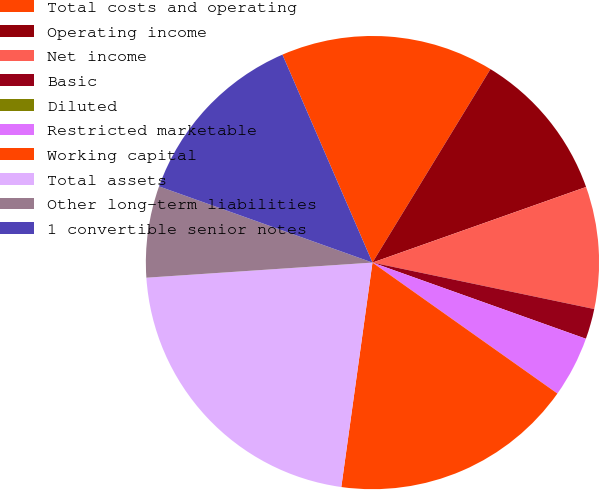<chart> <loc_0><loc_0><loc_500><loc_500><pie_chart><fcel>Total costs and operating<fcel>Operating income<fcel>Net income<fcel>Basic<fcel>Diluted<fcel>Restricted marketable<fcel>Working capital<fcel>Total assets<fcel>Other long-term liabilities<fcel>1 convertible senior notes<nl><fcel>15.22%<fcel>10.87%<fcel>8.7%<fcel>2.17%<fcel>0.0%<fcel>4.35%<fcel>17.39%<fcel>21.74%<fcel>6.52%<fcel>13.04%<nl></chart> 